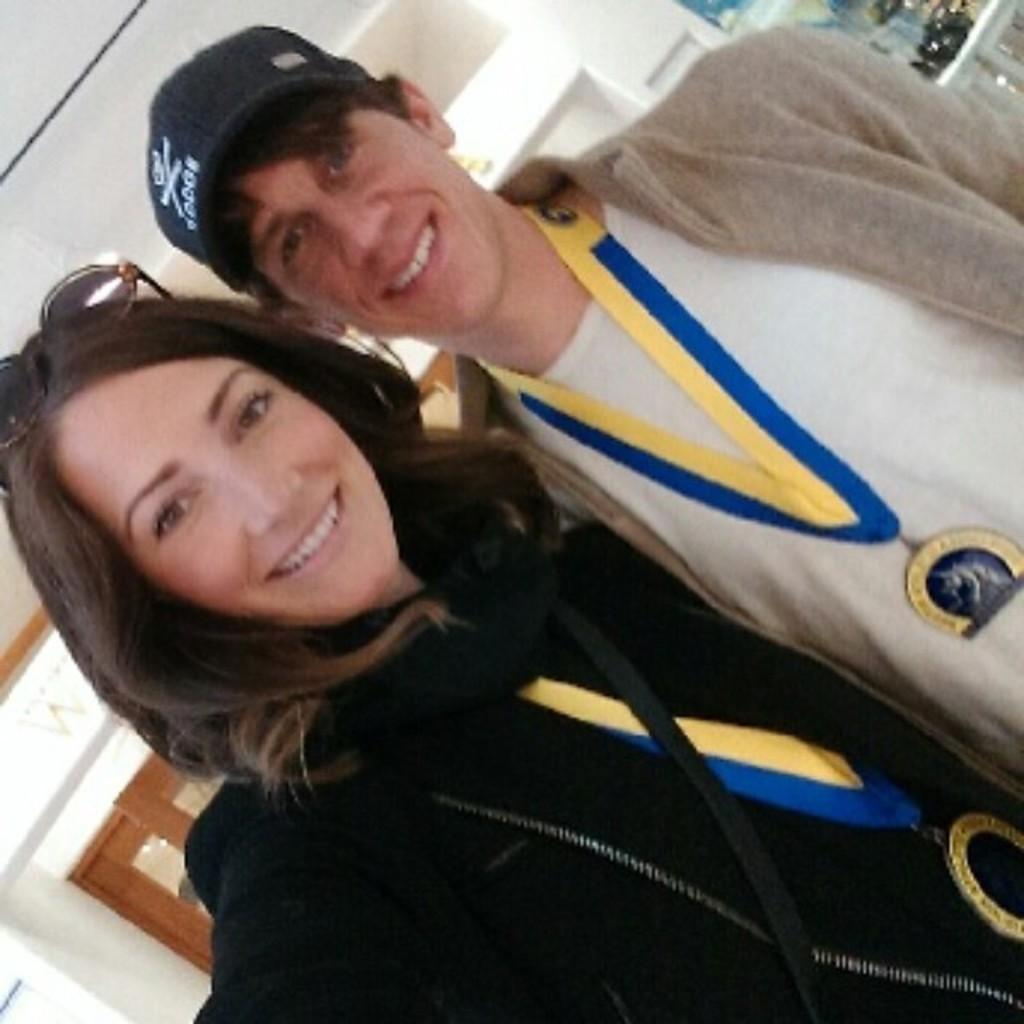How would you summarize this image in a sentence or two? In this image there are two persons woman and men , they both are smiling and men wearing a black color cap and woman wearing a black color t-shirt and back side of them I can see the wall. 